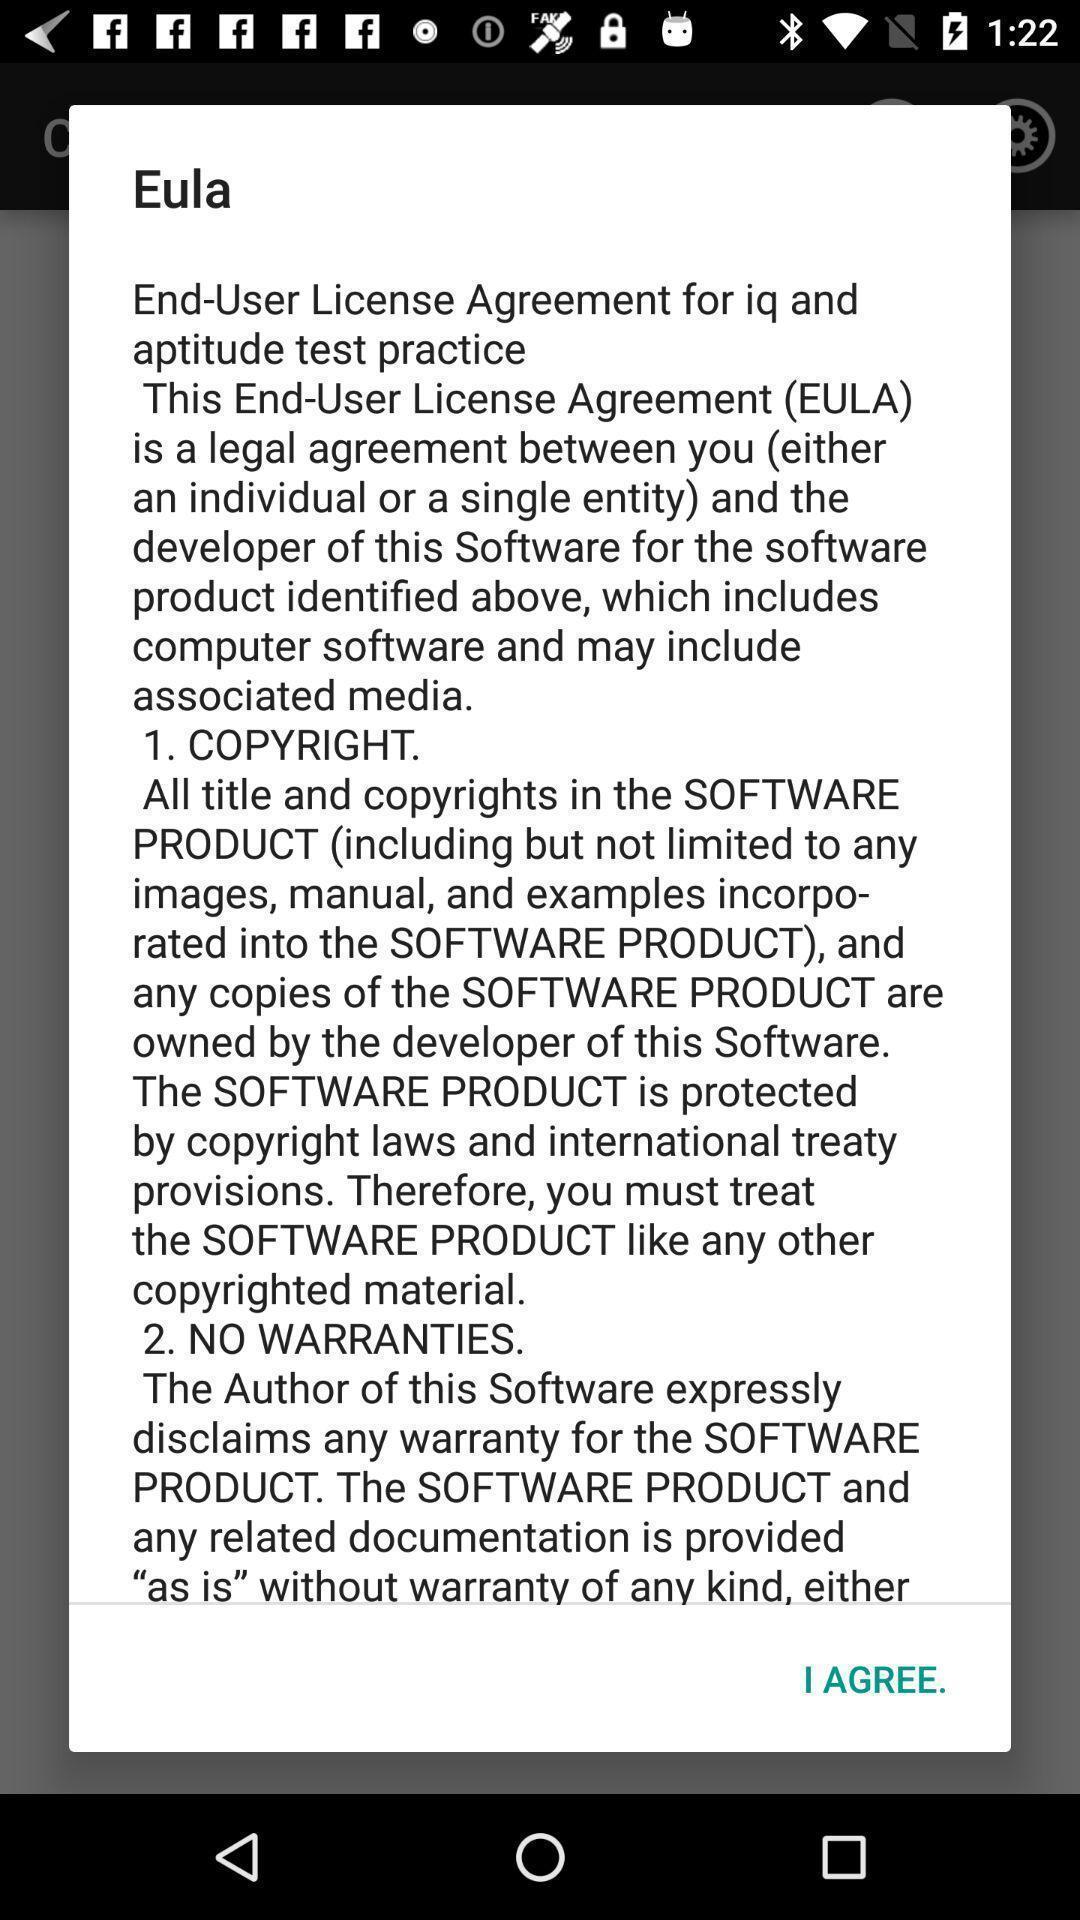Describe the key features of this screenshot. Pop up with license agreement information. 